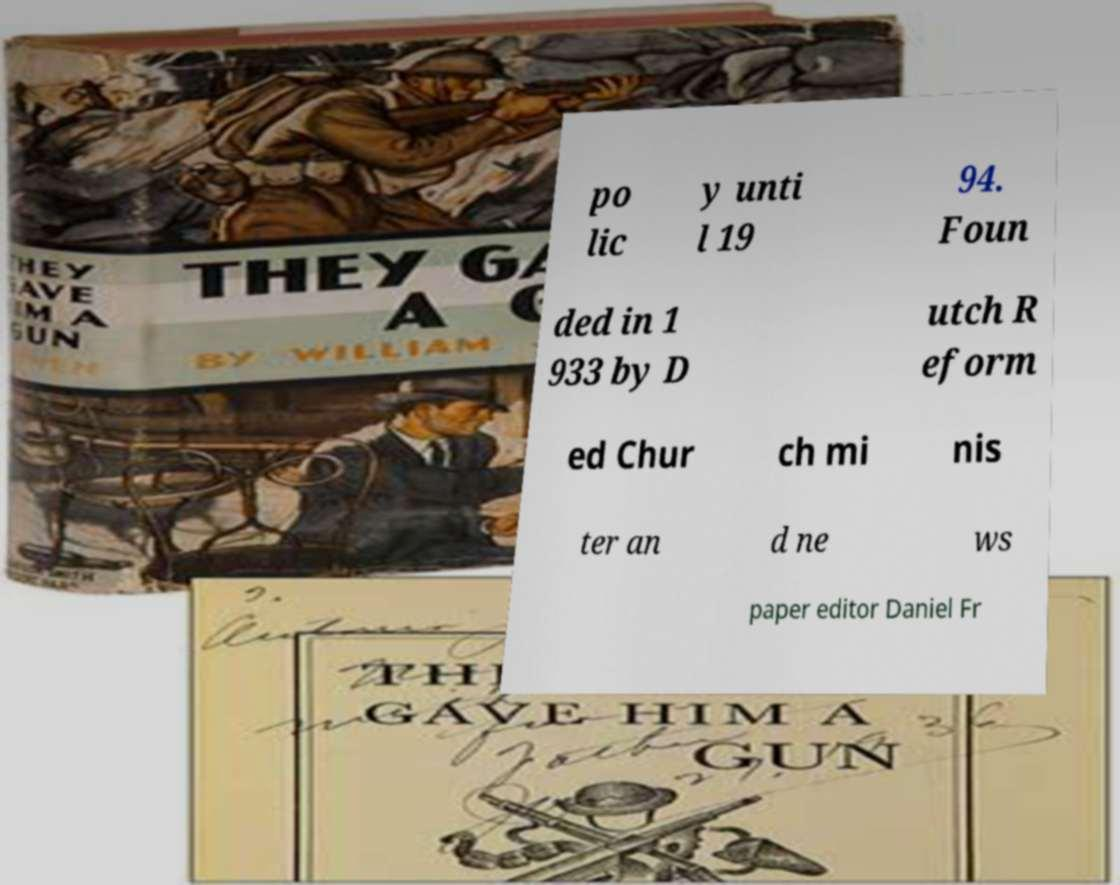There's text embedded in this image that I need extracted. Can you transcribe it verbatim? po lic y unti l 19 94. Foun ded in 1 933 by D utch R eform ed Chur ch mi nis ter an d ne ws paper editor Daniel Fr 